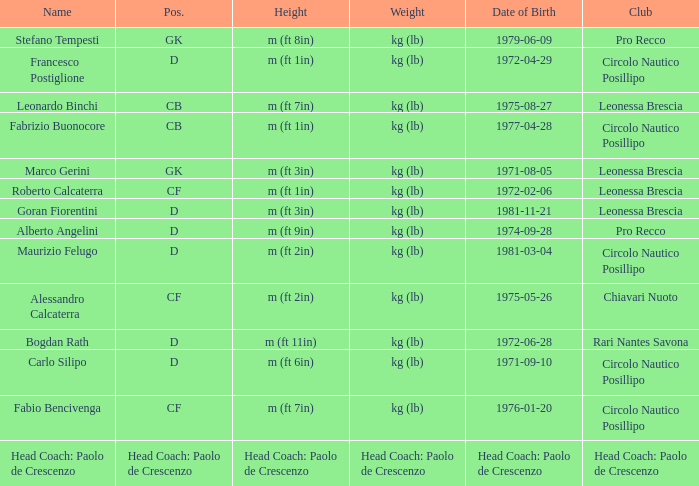What is the weight of the entry that has a date of birth of 1981-11-21? Kg (lb). 